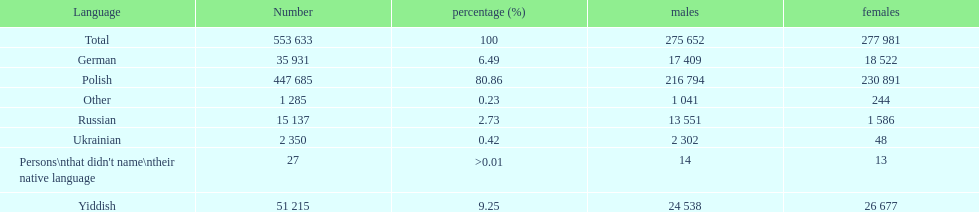Help me parse the entirety of this table. {'header': ['Language', 'Number', 'percentage (%)', 'males', 'females'], 'rows': [['Total', '553 633', '100', '275 652', '277 981'], ['German', '35 931', '6.49', '17 409', '18 522'], ['Polish', '447 685', '80.86', '216 794', '230 891'], ['Other', '1 285', '0.23', '1 041', '244'], ['Russian', '15 137', '2.73', '13 551', '1 586'], ['Ukrainian', '2 350', '0.42', '2 302', '48'], ["Persons\\nthat didn't name\\ntheir native language", '27', '>0.01', '14', '13'], ['Yiddish', '51 215', '9.25', '24 538', '26 677']]} How many languages have a name that is derived from a country? 4. 